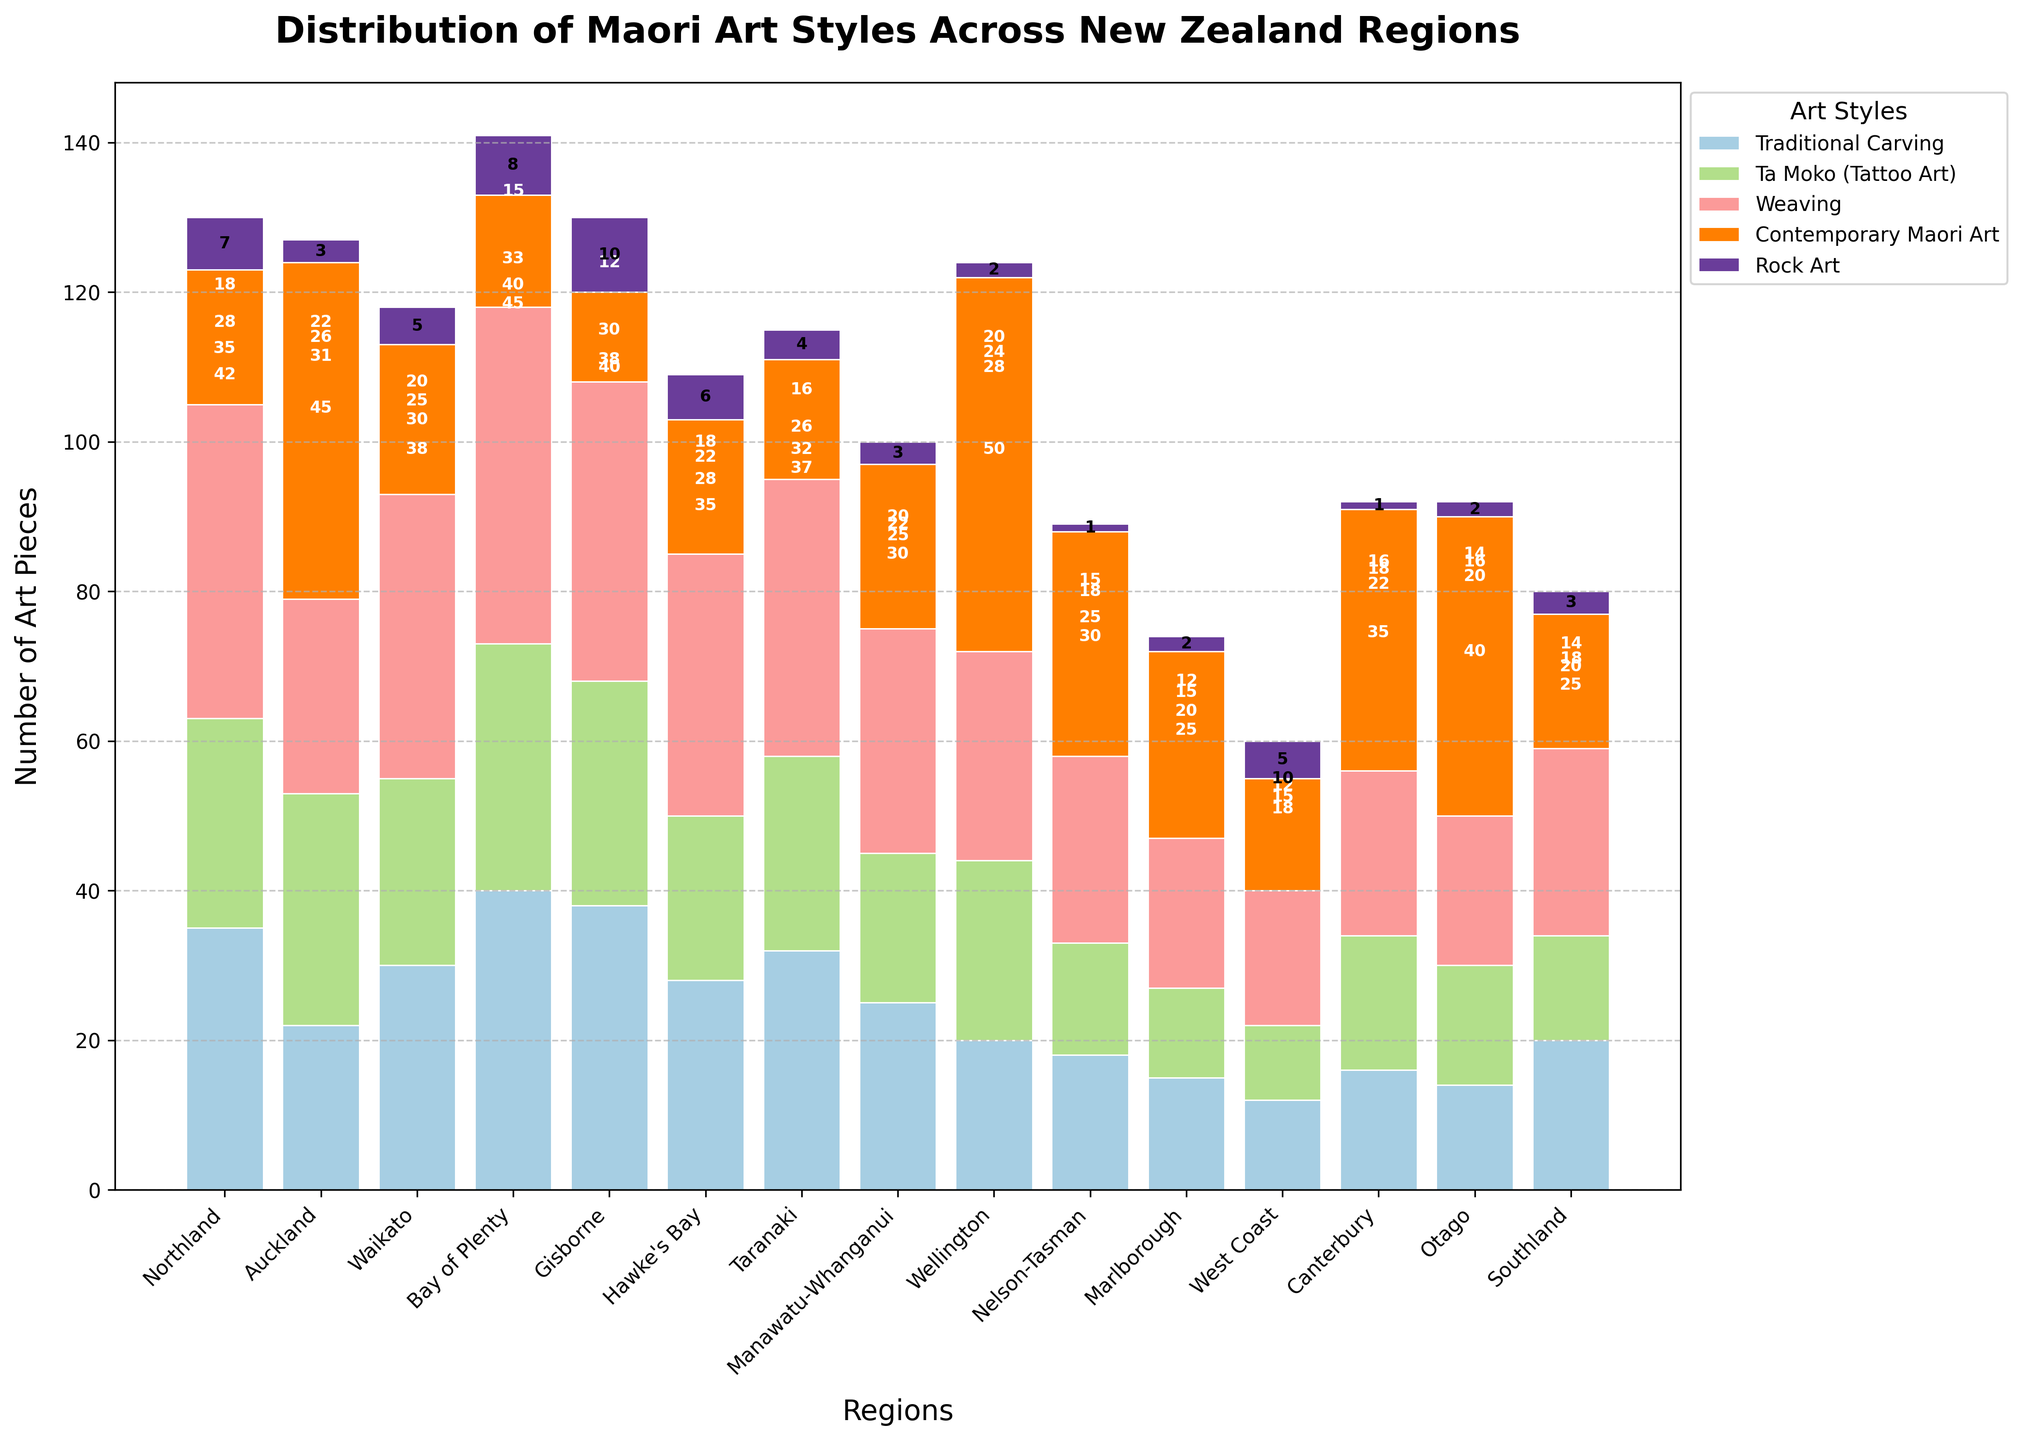How many more Traditional Carving pieces are there in Bay of Plenty compared to Canterbury? Look at the bars for Traditional Carving art style for Bay of Plenty and Canterbury. Bay of Plenty has 40 pieces, and Canterbury has 16. Subtract 16 from 40 to get the difference.
Answer: 24 In which region is Contemporary Maori Art the most prevalent, and what visual attribute indicates this? Check the height of the bars representing Contemporary Maori Art across all regions. The highest bar for this style is in Wellington. The bar's height is the key visual indicator.
Answer: Wellington Which regions have exactly 10 pieces of Rock Art? Identify bars representing Rock Art for all regions and look for those equal to 10 pieces. Based on the visual height, Gisborne has exactly 10 pieces.
Answer: Gisborne Compare the number of Weaving pieces in Northland and Auckland; where are there more, and by how many pieces? Look at the bars for Weaving in Northland and Auckland. Northland has 42 pieces, while Auckland has 26. Subtract 26 from 42 to find the difference.
Answer: Northland, 16 What is the total number of Ta Moko pieces in the North Island regions (Northland, Auckland, Waikato, Bay of Plenty, Gisborne, and Hawke's Bay)? Sum the Ta Moko (Tattoo Art) pieces for the North Island regions: Northland (28), Auckland (31), Waikato (25), Bay of Plenty (33), Gisborne (30), Hawke's Bay (22). The total is 28 + 31 + 25 + 33 + 30 + 22 = 169.
Answer: 169 Which two regions have the closest numbers of Traditional Carving pieces, and what are their differences? Look at the bars for Traditional Carving across all regions. Compare the heights to find the smallest difference. Taranaki has 32 and Waikato has 30, making a difference of 2 pieces.
Answer: Taranaki, Waikato, 2 How does the distribution of Maori art styles vary between the Northland and Otago regions? Compare the bars across all art styles for Northland and Otago. Northland has more Traditional Carving and Weaving. Otago has more Contemporary Maori Art. They are somewhat balanced in Rock Art.
Answer: Northland has more in Traditional Carving and Weaving, Otago has more in Contemporary Maori Art In which South Island region are there at least 30 pieces of Contemporary Maori Art? Look at the bars representing Contemporary Maori Art in the South Island regions. Nelson-Tasman has 30 pieces, as indicated by the bar's height.
Answer: Nelson-Tasman What is the average number of Rock Art pieces reported across all regions? Sum the Rock Art pieces across all regions and divide by the number of regions (15). The total is 7 + 3 + 5 + 8 + 10 + 6 + 4 + 3 + 2 + 1 + 2 + 5 + 1 + 2 + 3 = 62. The average is 62/15 ≈ 4.1.
Answer: 4.1 If we combine the number of Weaving pieces from Northland, Bay of Plenty, and Waikato, will they exceed 100? Look at the number of Weaving pieces in Northland (42), Bay of Plenty (45), and Waikato (38). Sum them up: 42 + 45 + 38 = 125, which exceeds 100.
Answer: Yes, 125 